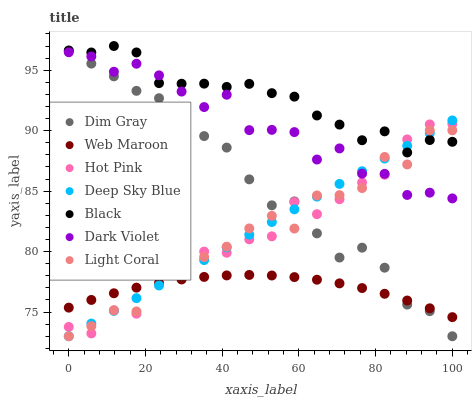Does Web Maroon have the minimum area under the curve?
Answer yes or no. Yes. Does Black have the maximum area under the curve?
Answer yes or no. Yes. Does Hot Pink have the minimum area under the curve?
Answer yes or no. No. Does Hot Pink have the maximum area under the curve?
Answer yes or no. No. Is Deep Sky Blue the smoothest?
Answer yes or no. Yes. Is Light Coral the roughest?
Answer yes or no. Yes. Is Hot Pink the smoothest?
Answer yes or no. No. Is Hot Pink the roughest?
Answer yes or no. No. Does Dim Gray have the lowest value?
Answer yes or no. Yes. Does Hot Pink have the lowest value?
Answer yes or no. No. Does Black have the highest value?
Answer yes or no. Yes. Does Hot Pink have the highest value?
Answer yes or no. No. Is Web Maroon less than Dark Violet?
Answer yes or no. Yes. Is Dark Violet greater than Web Maroon?
Answer yes or no. Yes. Does Light Coral intersect Deep Sky Blue?
Answer yes or no. Yes. Is Light Coral less than Deep Sky Blue?
Answer yes or no. No. Is Light Coral greater than Deep Sky Blue?
Answer yes or no. No. Does Web Maroon intersect Dark Violet?
Answer yes or no. No. 